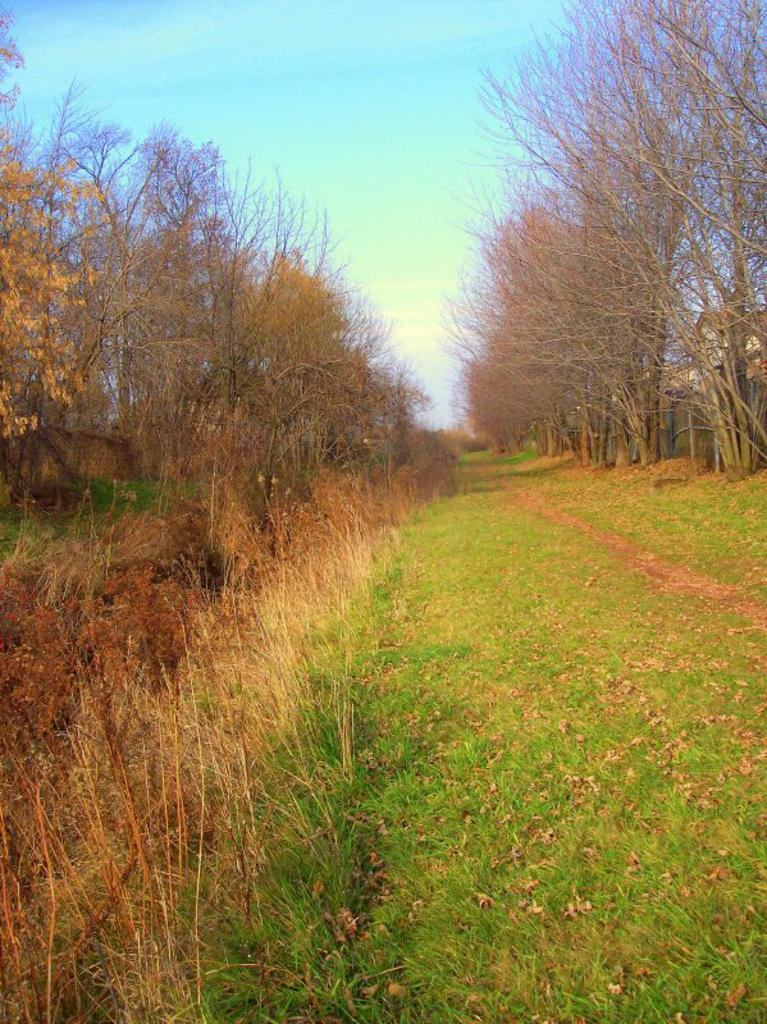What type of vegetation is present in the picture? There is grass in the picture. Where are the trees located in the picture? There are trees on both the left and right sides of the picture. What color is the sky in the picture? The sky is blue in the picture. What type of string can be seen connecting the trees in the picture? There is no string connecting the trees in the picture; only the grass, trees, and blue sky are present. What scientific experiment is being conducted in the picture? There is no scientific experiment depicted in the picture; it simply shows grass, trees, and a blue sky. 